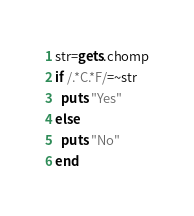<code> <loc_0><loc_0><loc_500><loc_500><_Ruby_>str=gets.chomp
if /.*C.*F/=~str 
  puts "Yes" 
else
  puts "No"
end</code> 